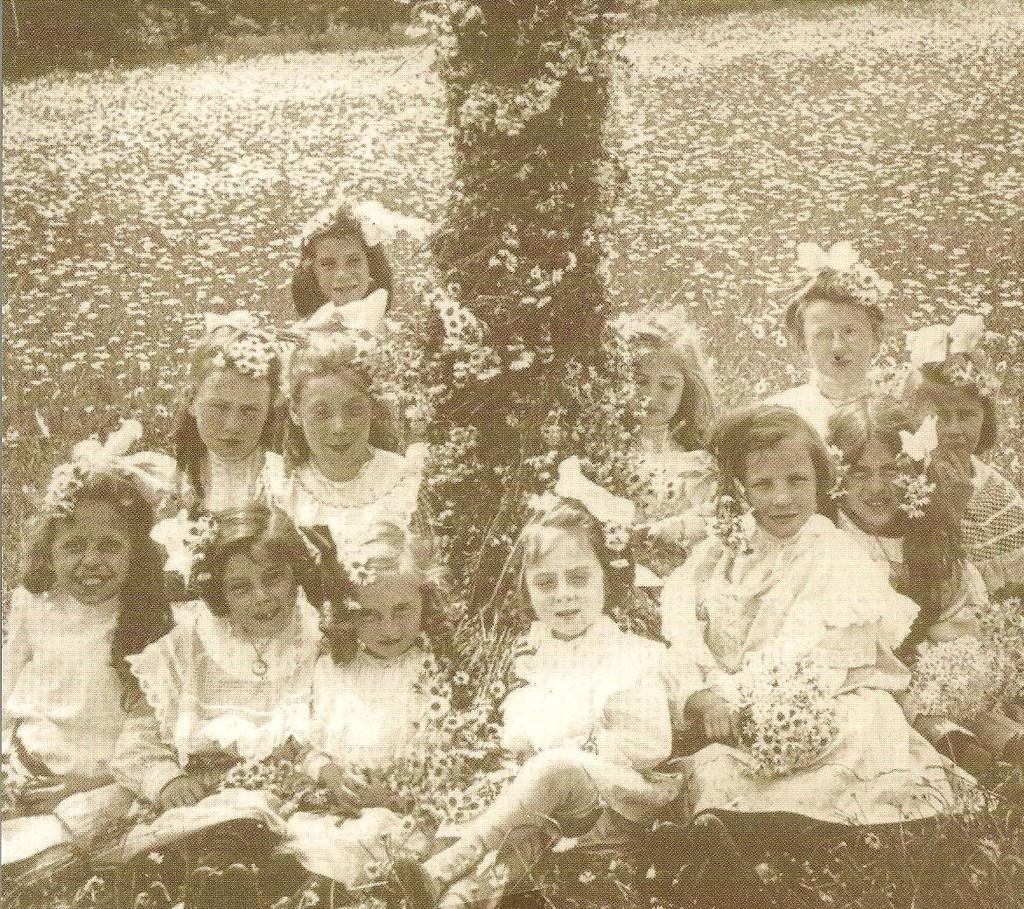What is the main subject of the image? The main subject of the image is a group of girls. What are the girls doing in the image? The girls are sitting in the image. What are the girls wearing in the image? The girls are wearing white dresses in the image. What is the color scheme of the image? The image is black and white. Can you tell me how many partners each girl has in the image? There is no mention of partners in the image; it features a group of girls sitting and wearing white dresses. What type of elbow is visible in the image? There is no mention of elbows in the image; it focuses on a group of girls sitting and wearing white dresses. 